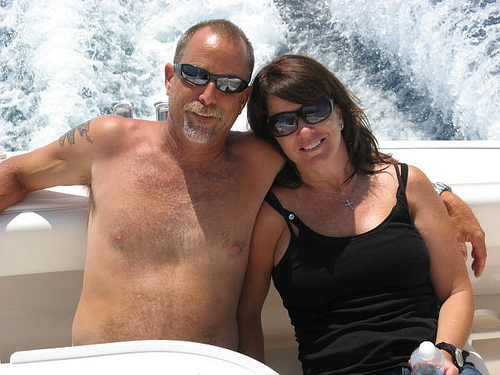<image>
Is there a man on the woman? No. The man is not positioned on the woman. They may be near each other, but the man is not supported by or resting on top of the woman. Is the lady to the left of the man? Yes. From this viewpoint, the lady is positioned to the left side relative to the man. Is the aunty to the left of the uncle? No. The aunty is not to the left of the uncle. From this viewpoint, they have a different horizontal relationship. Is there a woman behind the man? No. The woman is not behind the man. From this viewpoint, the woman appears to be positioned elsewhere in the scene. 